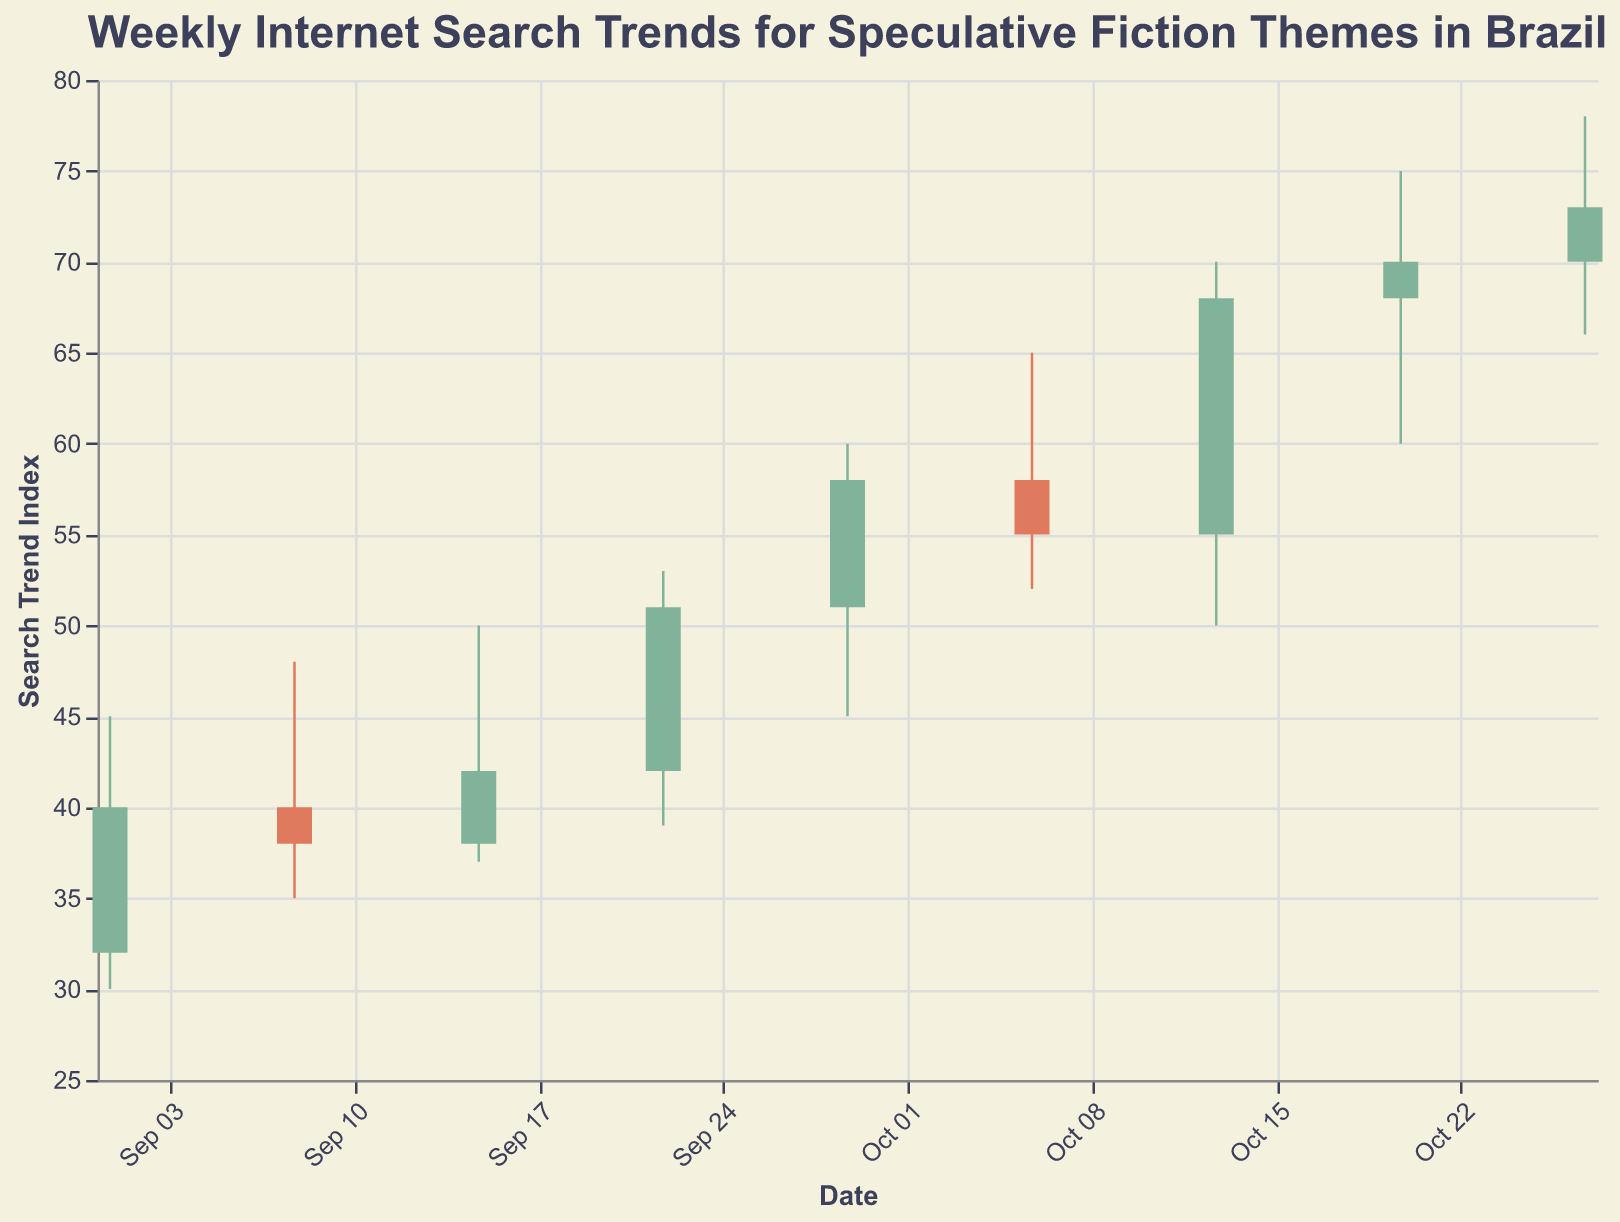What is the title of the plot? The title of the plot is placed at the top and provides a brief description of the visualized data.
Answer: Weekly Internet Search Trends for Speculative Fiction Themes in Brazil What is the highest search trend index recorded in the plot? The highest trend index can be identified by looking at the tallest upper shadow (High) among all the candlesticks.
Answer: 78 In which week did the closing value exceed the opening value by the largest margin? To find this, calculate the difference between Close and Open for each week and identify the week with the maximum difference. Week of October 13: 68 - 55 = 13
Answer: Week of October 13 How many weeks show a decline in the search trend from the opening to closing value? A decline is indicated by a Close value less than the Open value, represented by candlesticks of a certain color. Count the weeks where this is observed.
Answer: 2 weeks Which week experienced the largest range between the highest and lowest search trend indices? Calculate the difference between High and Low for each week and find the maximum difference. September 29: 60 - 45 = 15
Answer: Week of September 29 During which week did the opening search trend index start at 70? Look for the week where the Open value is 70.
Answer: October 27 Compare the closing values on September 1 and October 27. Which one is higher? By comparing the Close values of the specified dates, we can determine which one is higher. September 1: 40, October 27: 73
Answer: October 27 What trend can you observe in the search indices from September 15 to September 29? Analyze the weekly changes in both the opening and closing indices between the given dates.
Answer: The trend is an upward increase in the indices Find the week with the smallest difference between the High and Low values. Calculate the difference between High and Low for each week and identify the week with the smallest difference. Week of October 13: 70 - 50 = 20
Answer: Week of October 13 